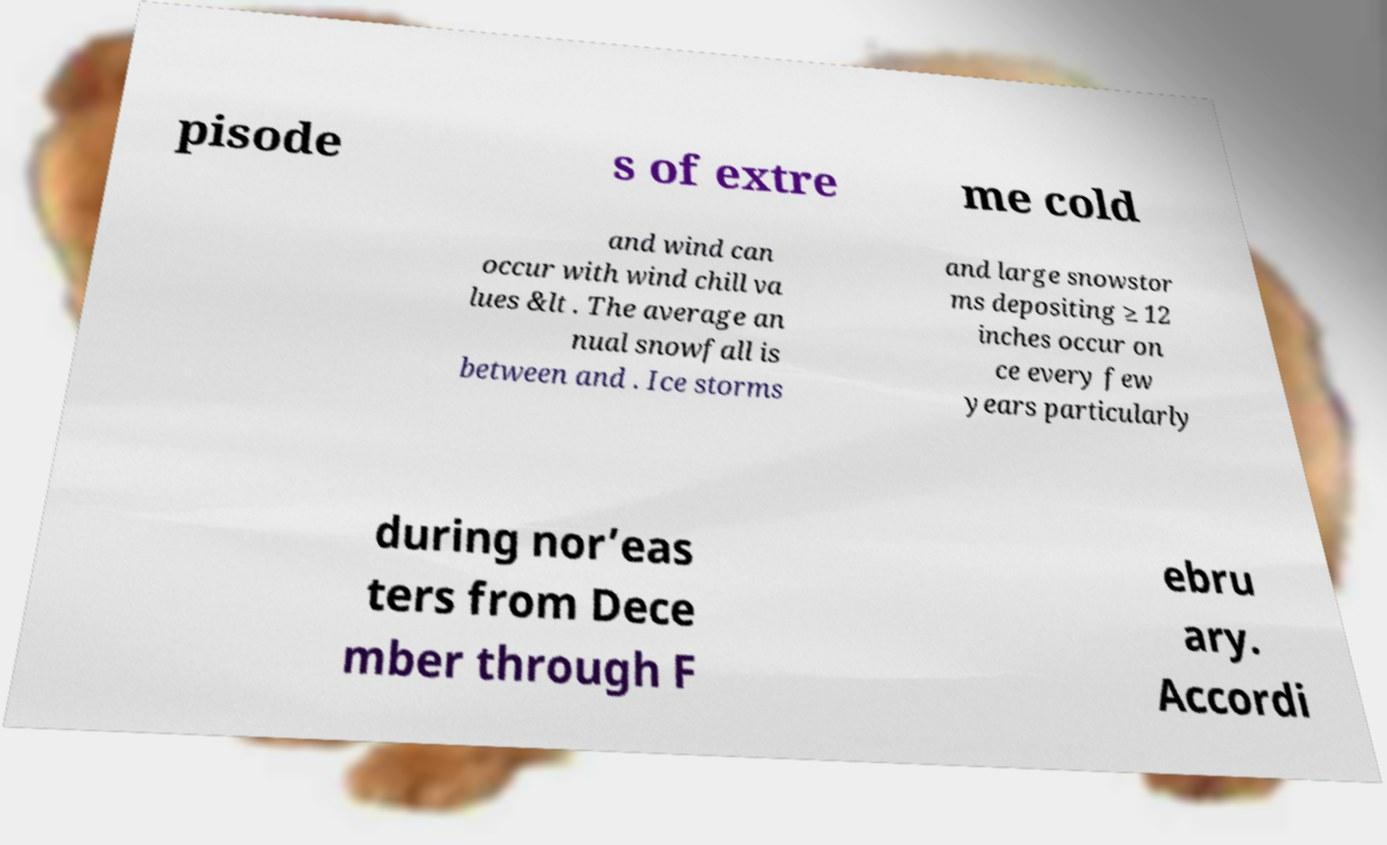Could you extract and type out the text from this image? pisode s of extre me cold and wind can occur with wind chill va lues &lt . The average an nual snowfall is between and . Ice storms and large snowstor ms depositing ≥ 12 inches occur on ce every few years particularly during nor’eas ters from Dece mber through F ebru ary. Accordi 